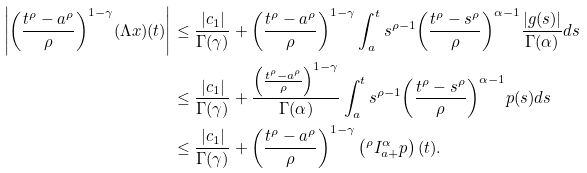Convert formula to latex. <formula><loc_0><loc_0><loc_500><loc_500>\left | { \left ( \frac { t ^ { \rho } - a ^ { \rho } } { \rho } \right ) } ^ { 1 - \gamma } ( \Lambda { x } ) ( t ) \right | & \leq \frac { | c _ { 1 } | } { \Gamma ( \gamma ) } + { \left ( \frac { t ^ { \rho } - a ^ { \rho } } { \rho } \right ) } ^ { 1 - \gamma } \int _ { a } ^ { t } s ^ { \rho - 1 } { \left ( \frac { t ^ { \rho } - s ^ { \rho } } { \rho } \right ) } ^ { \alpha - 1 } \frac { | g ( s ) | } { \Gamma ( \alpha ) } d s \\ & \leq \frac { | c _ { 1 } | } { \Gamma ( \gamma ) } + \frac { { \left ( \frac { t ^ { \rho } - a ^ { \rho } } { \rho } \right ) } ^ { 1 - \gamma } } { \Gamma ( \alpha ) } \int _ { a } ^ { t } s ^ { \rho - 1 } { \left ( \frac { t ^ { \rho } - s ^ { \rho } } { \rho } \right ) } ^ { \alpha - 1 } p ( s ) d s \\ & \leq \frac { | c _ { 1 } | } { \Gamma ( \gamma ) } + { \left ( \frac { t ^ { \rho } - a ^ { \rho } } { \rho } \right ) } ^ { 1 - \gamma } \left ( { ^ { \rho } { I } _ { a + } ^ { \alpha } p } \right ) ( t ) .</formula> 